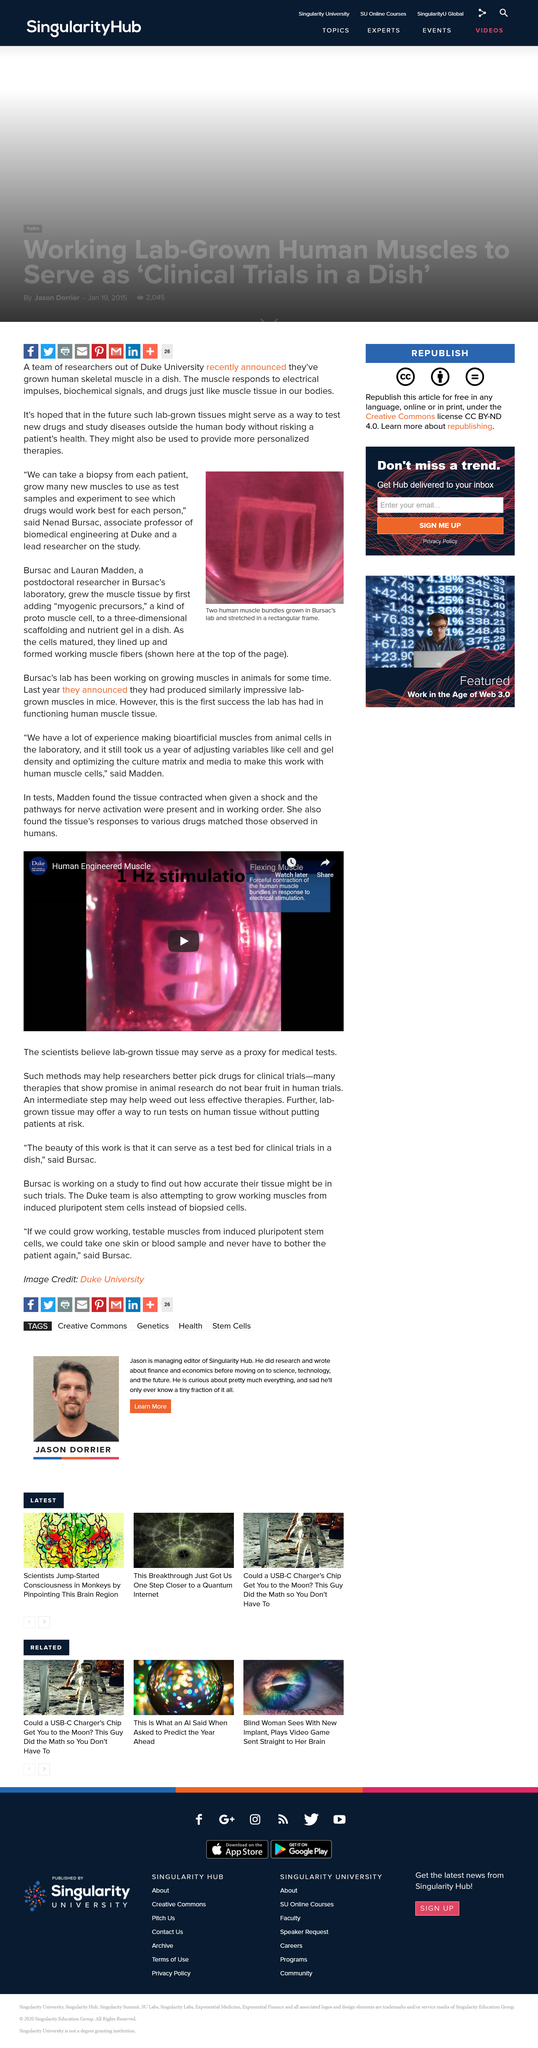Point out several critical features in this image. Myogenic precursor cells are the progenitor cells that give rise to muscle cells. Nenad Bursac is an associate professor of biomedical engineering at Duke University who specializes in the field of biomedical engineering. Researchers in Bursac's lab are growing two human muscle bundles in a rectangular frame, as seen in the photograph. 